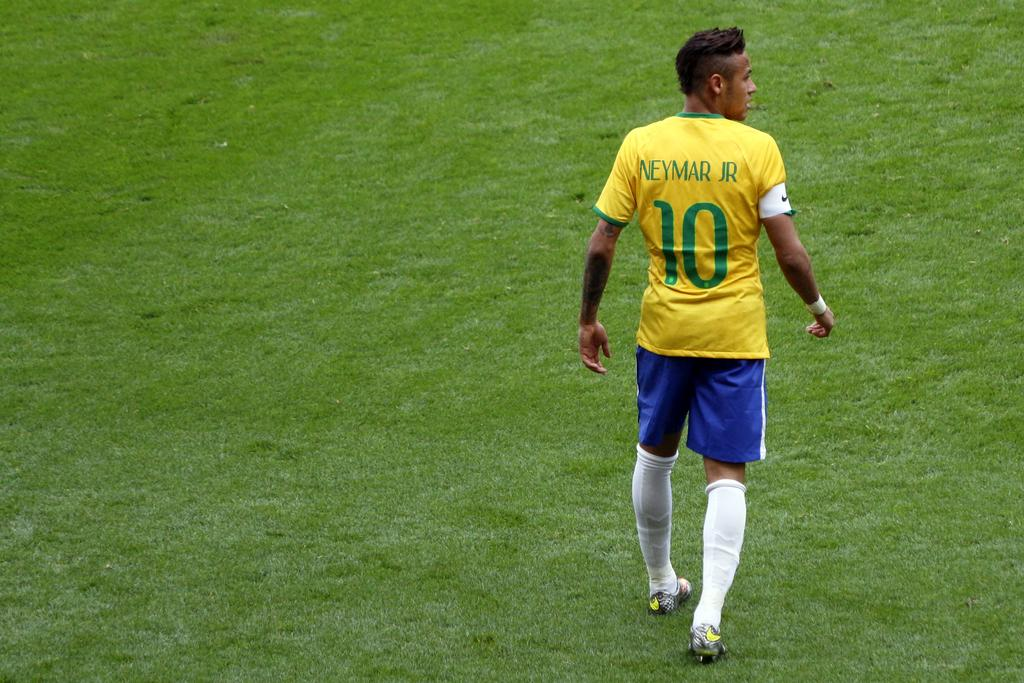<image>
Relay a brief, clear account of the picture shown. a soccer player with the number 10 on their back 